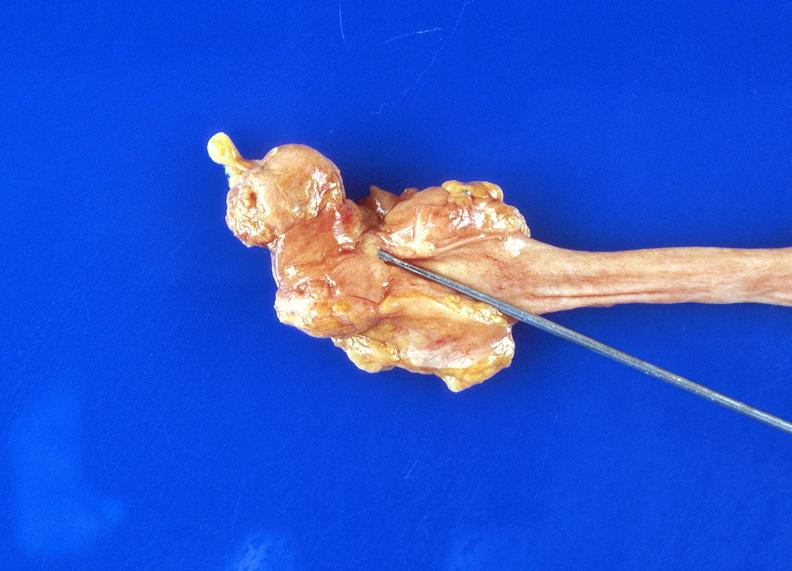where is this?
Answer the question using a single word or phrase. Urinary 